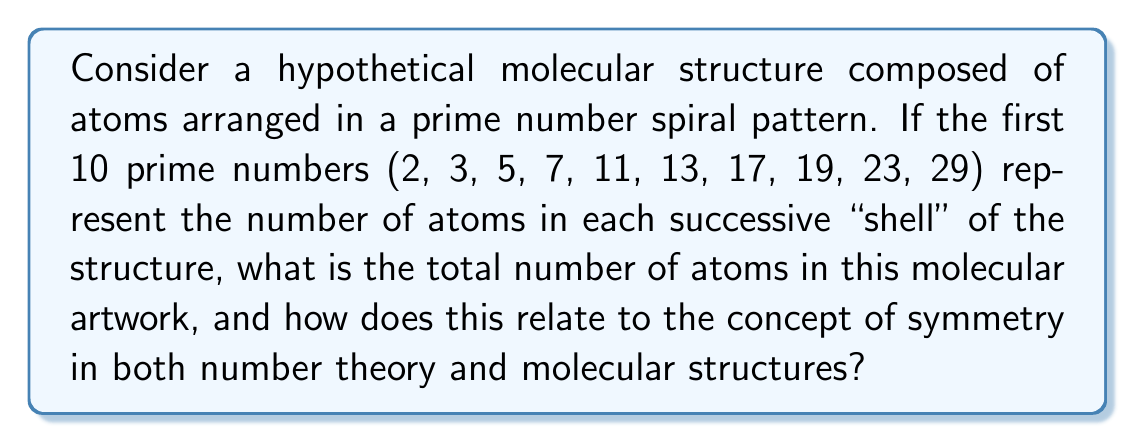Provide a solution to this math problem. Let's approach this step-by-step:

1) First, we need to sum the first 10 prime numbers:
   $$2 + 3 + 5 + 7 + 11 + 13 + 17 + 19 + 23 + 29$$

2) We can calculate this sum:
   $$2 + 3 + 5 + 7 + 11 + 13 + 17 + 19 + 23 + 29 = 129$$

3) The total number of atoms in the structure is 129.

4) Now, let's consider the symmetry aspects:

   a) In number theory, prime numbers are considered the "building blocks" of all integers, similar to how atoms are the building blocks of molecules.

   b) The prime number spiral (also known as Ulam spiral) reveals unexpected patterns and symmetries in the distribution of prime numbers, much like how molecular structures often exhibit surprising symmetries.

   c) The sum we calculated (129) is not itself a prime number. It can be factored as $3 \times 43$. This lack of primality in the total could be seen as breaking perfect symmetry, which is often the case in complex molecular structures.

   d) The increasing number of atoms in each shell (as we move outward following the prime number sequence) creates a form of radial symmetry, which is common in many molecular structures, especially those inspired by natural forms.

5) In molecular symmetry, we often see repeating units or patterns. While prime numbers don't repeat, their distribution shows certain patterns and clustering, which could be analogous to the arrangement of atomic subunits in complex molecules.

6) The prime number spiral, when visualized, creates a pattern that's neither completely random nor perfectly regular - a characteristic shared by many organic molecular structures that inspire artists and scientists alike.
Answer: 129 atoms; both exhibit complex, imperfect symmetries 